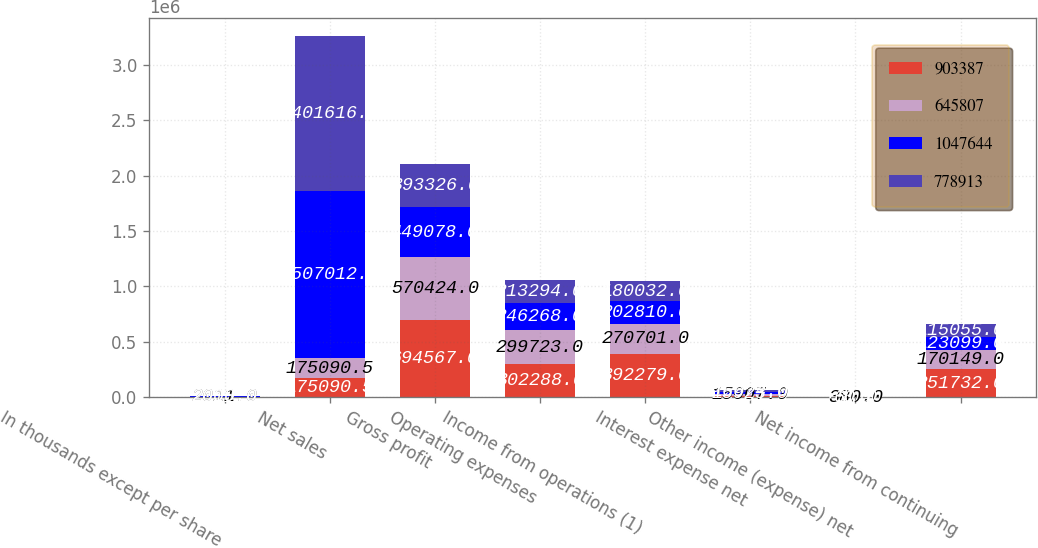Convert chart to OTSL. <chart><loc_0><loc_0><loc_500><loc_500><stacked_bar_chart><ecel><fcel>In thousands except per share<fcel>Net sales<fcel>Gross profit<fcel>Operating expenses<fcel>Income from operations (1)<fcel>Interest expense net<fcel>Other income (expense) net<fcel>Net income from continuing<nl><fcel>903387<fcel>2012<fcel>175090<fcel>694567<fcel>302288<fcel>392279<fcel>14251<fcel>670<fcel>251732<nl><fcel>645807<fcel>2011<fcel>175090<fcel>570424<fcel>299723<fcel>270701<fcel>15007<fcel>380<fcel>170149<nl><fcel>1.04764e+06<fcel>2010<fcel>1.50701e+06<fcel>449078<fcel>246268<fcel>202810<fcel>15923<fcel>60<fcel>123099<nl><fcel>778913<fcel>2009<fcel>1.40162e+06<fcel>393326<fcel>213294<fcel>180032<fcel>16674<fcel>1<fcel>115055<nl></chart> 